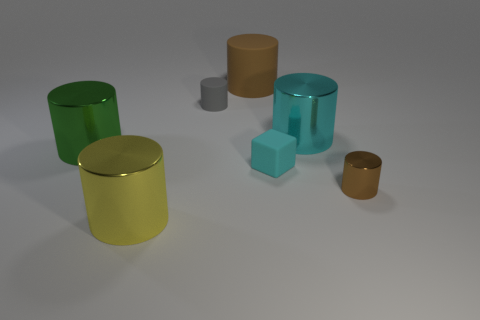What is the shape of the big brown thing that is the same material as the cyan cube?
Keep it short and to the point. Cylinder. There is a rubber object that is left of the large matte thing; is its shape the same as the small brown object?
Provide a succinct answer. Yes. What shape is the tiny rubber thing that is behind the big green metal cylinder?
Keep it short and to the point. Cylinder. What shape is the object that is the same color as the large matte cylinder?
Provide a succinct answer. Cylinder. How many green rubber balls are the same size as the gray matte thing?
Your answer should be very brief. 0. What is the color of the big matte object?
Give a very brief answer. Brown. There is a small matte cylinder; is its color the same as the shiny thing that is to the left of the big yellow thing?
Provide a succinct answer. No. There is a gray thing that is the same material as the big brown cylinder; what is its size?
Offer a terse response. Small. Are there any matte objects that have the same color as the small shiny cylinder?
Provide a succinct answer. Yes. What number of objects are small rubber objects that are in front of the cyan metal cylinder or cyan matte blocks?
Ensure brevity in your answer.  1. 